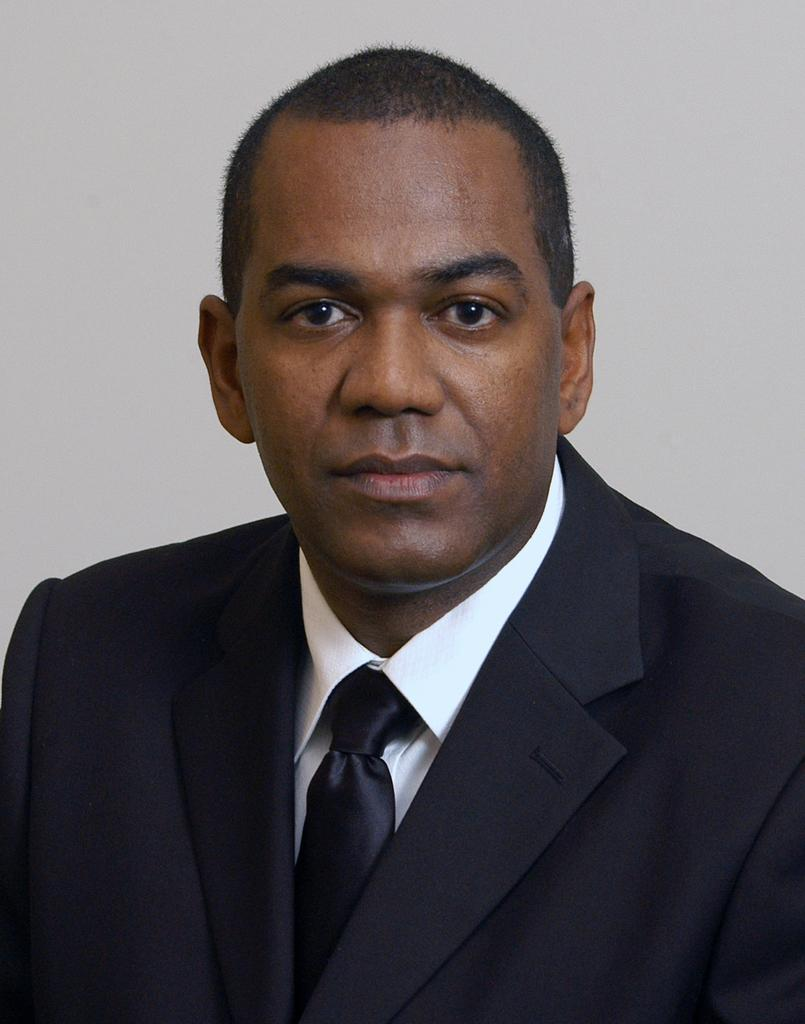Who is the main subject in the image? There is a man in the center of the image. What is the man wearing in the image? The man is wearing a coat and a tie. What can be seen in the background of the image? There is a wall in the background of the image. How much does the turkey cost in the image? There is no turkey present in the image, so it is not possible to determine its cost. 